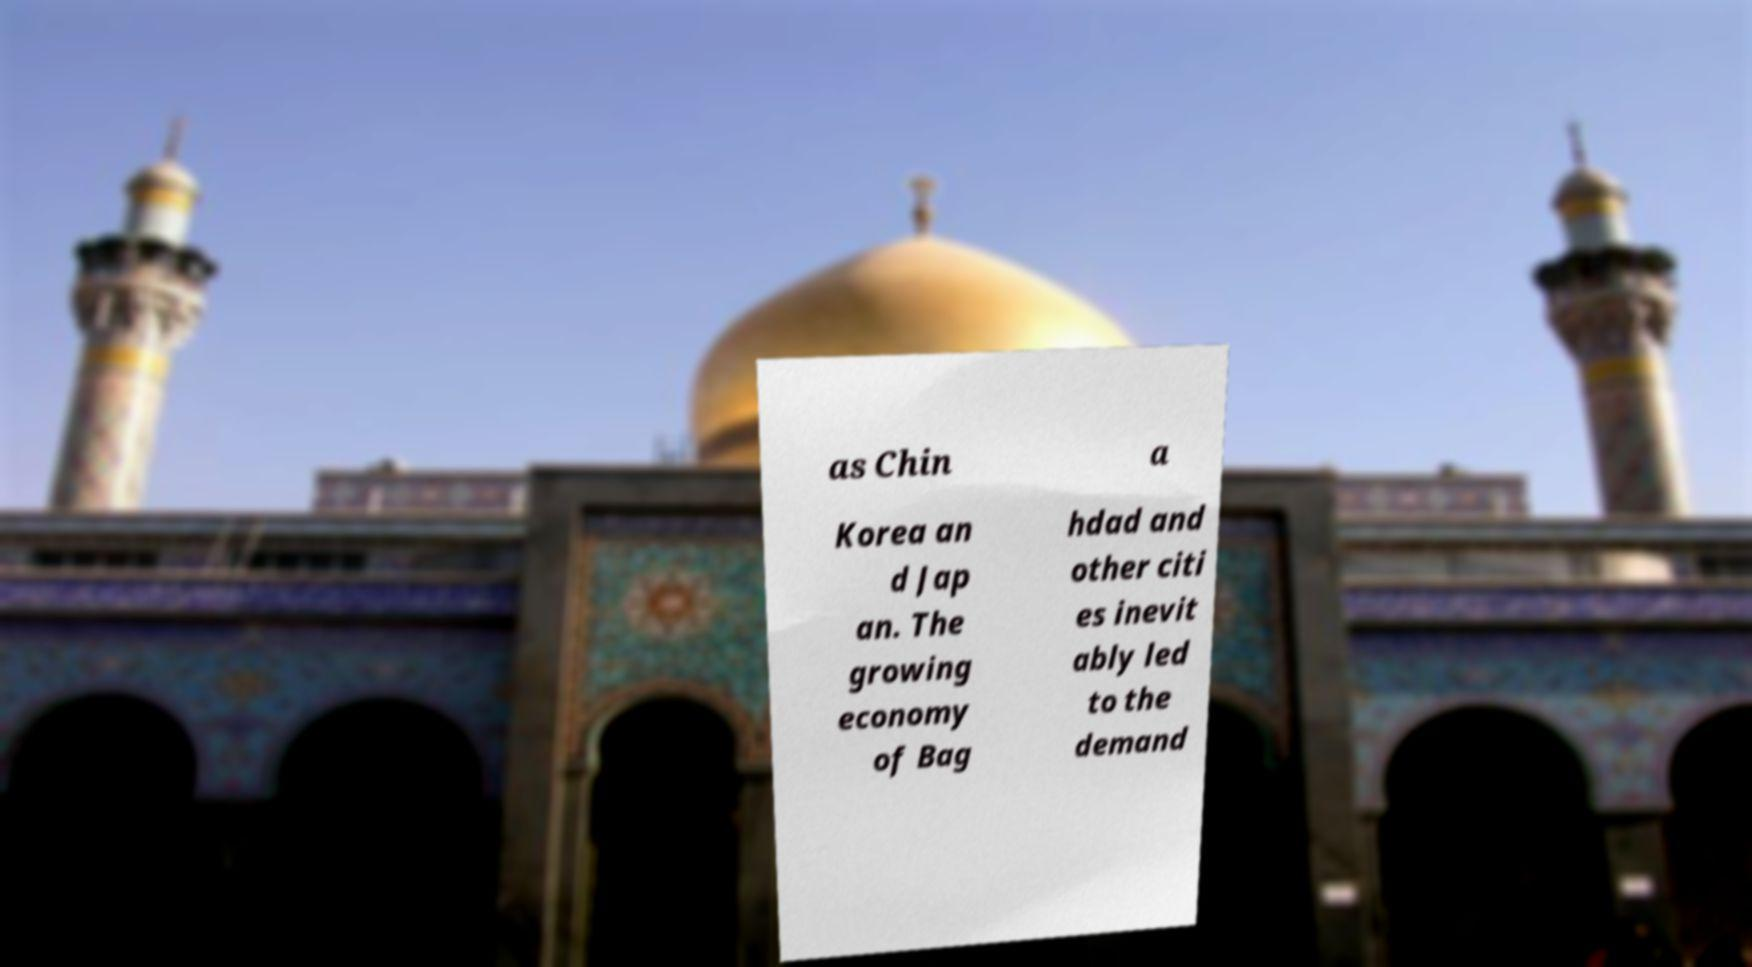Please read and relay the text visible in this image. What does it say? as Chin a Korea an d Jap an. The growing economy of Bag hdad and other citi es inevit ably led to the demand 